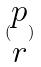<formula> <loc_0><loc_0><loc_500><loc_500>( \begin{matrix} p \\ r \end{matrix} )</formula> 